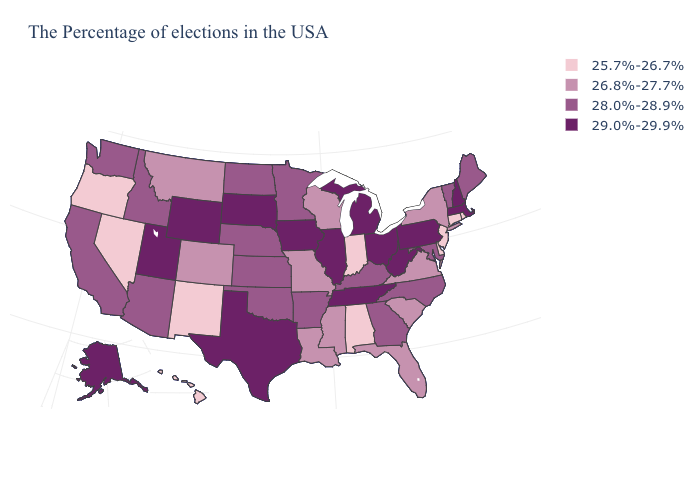Among the states that border California , which have the lowest value?
Write a very short answer. Nevada, Oregon. What is the value of Oklahoma?
Quick response, please. 28.0%-28.9%. Which states have the lowest value in the USA?
Keep it brief. Rhode Island, Connecticut, New Jersey, Delaware, Indiana, Alabama, New Mexico, Nevada, Oregon, Hawaii. Among the states that border Illinois , does Indiana have the lowest value?
Concise answer only. Yes. Does the first symbol in the legend represent the smallest category?
Concise answer only. Yes. What is the highest value in the USA?
Be succinct. 29.0%-29.9%. What is the highest value in the South ?
Short answer required. 29.0%-29.9%. Does the first symbol in the legend represent the smallest category?
Give a very brief answer. Yes. What is the value of Iowa?
Quick response, please. 29.0%-29.9%. Among the states that border Nevada , which have the highest value?
Concise answer only. Utah. How many symbols are there in the legend?
Concise answer only. 4. What is the lowest value in states that border Nebraska?
Be succinct. 26.8%-27.7%. Name the states that have a value in the range 29.0%-29.9%?
Keep it brief. Massachusetts, New Hampshire, Pennsylvania, West Virginia, Ohio, Michigan, Tennessee, Illinois, Iowa, Texas, South Dakota, Wyoming, Utah, Alaska. Name the states that have a value in the range 26.8%-27.7%?
Quick response, please. New York, Virginia, South Carolina, Florida, Wisconsin, Mississippi, Louisiana, Missouri, Colorado, Montana. 